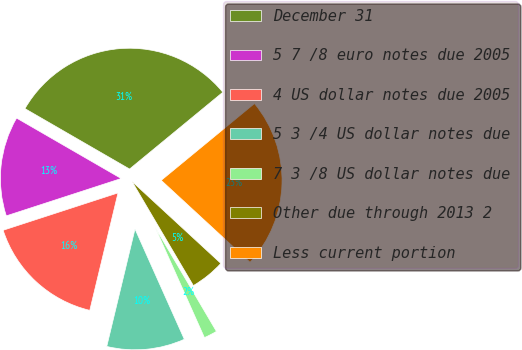Convert chart to OTSL. <chart><loc_0><loc_0><loc_500><loc_500><pie_chart><fcel>December 31<fcel>5 7 /8 euro notes due 2005<fcel>4 US dollar notes due 2005<fcel>5 3 /4 US dollar notes due<fcel>7 3 /8 US dollar notes due<fcel>Other due through 2013 2<fcel>Less current portion<nl><fcel>30.7%<fcel>13.34%<fcel>16.24%<fcel>10.45%<fcel>1.78%<fcel>4.67%<fcel>22.82%<nl></chart> 